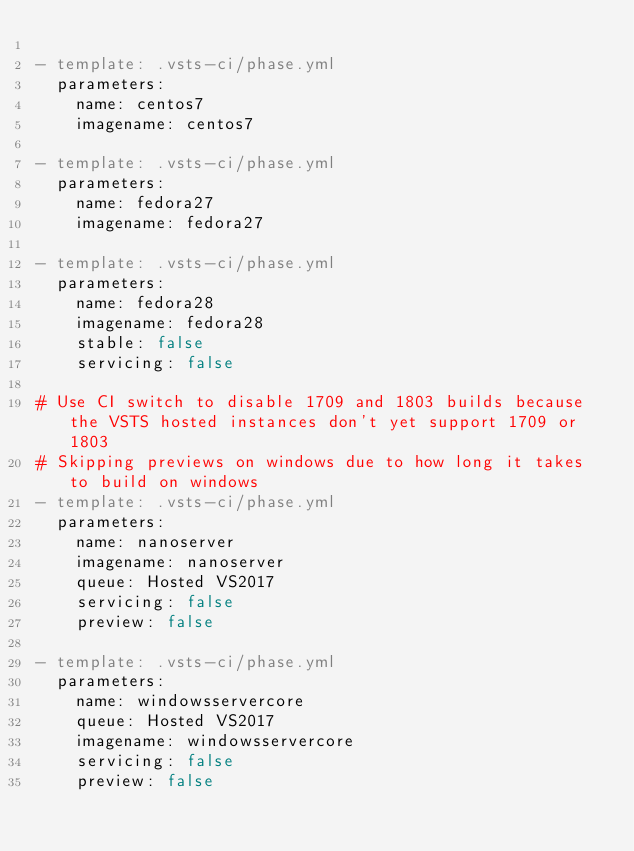<code> <loc_0><loc_0><loc_500><loc_500><_YAML_>
- template: .vsts-ci/phase.yml
  parameters:
    name: centos7
    imagename: centos7

- template: .vsts-ci/phase.yml
  parameters:
    name: fedora27
    imagename: fedora27

- template: .vsts-ci/phase.yml
  parameters:
    name: fedora28
    imagename: fedora28
    stable: false
    servicing: false

# Use CI switch to disable 1709 and 1803 builds because the VSTS hosted instances don't yet support 1709 or 1803
# Skipping previews on windows due to how long it takes to build on windows
- template: .vsts-ci/phase.yml
  parameters:
    name: nanoserver
    imagename: nanoserver
    queue: Hosted VS2017
    servicing: false
    preview: false

- template: .vsts-ci/phase.yml
  parameters:
    name: windowsservercore
    queue: Hosted VS2017
    imagename: windowsservercore
    servicing: false
    preview: false
</code> 